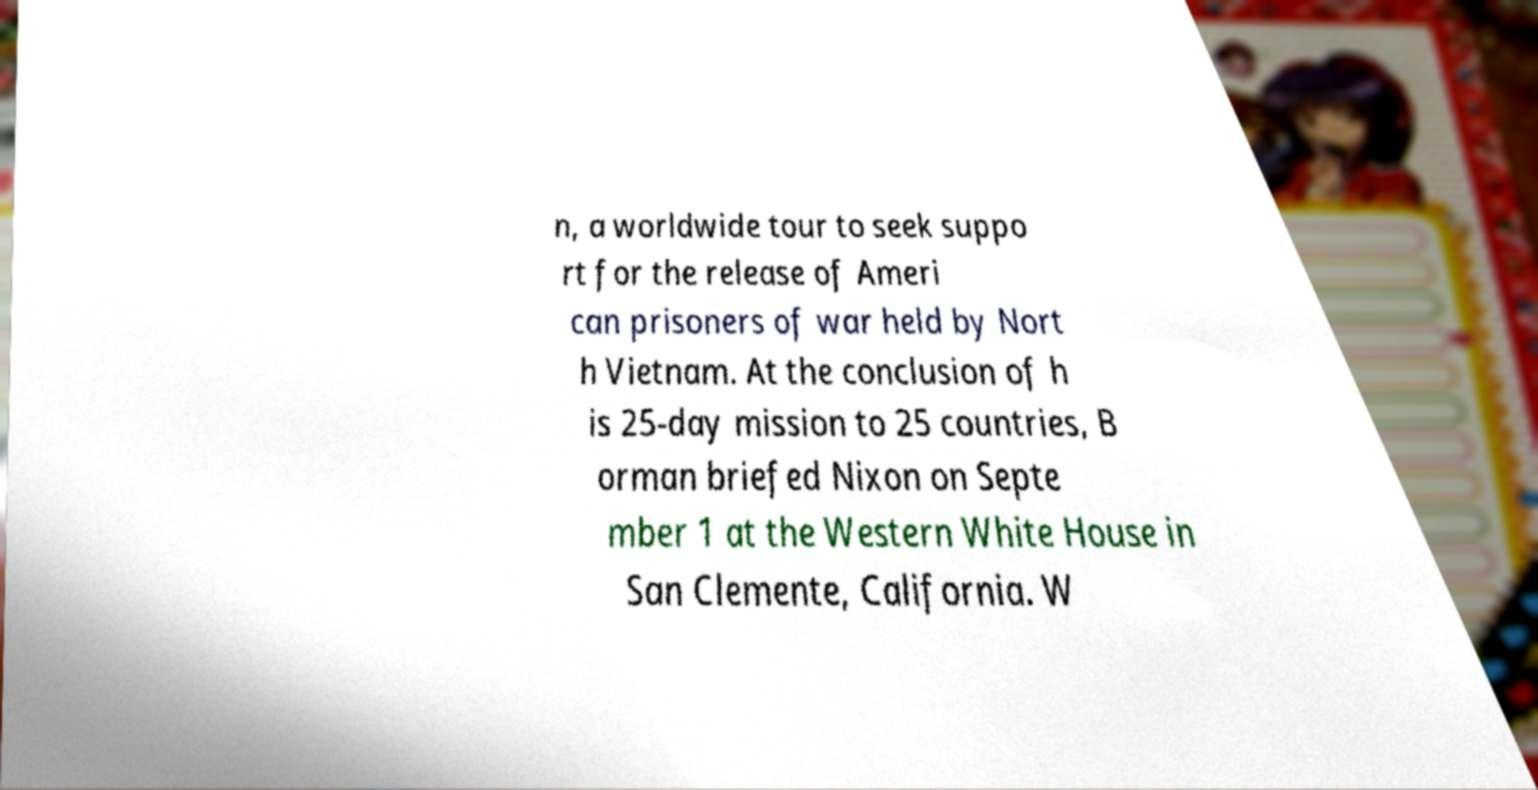I need the written content from this picture converted into text. Can you do that? n, a worldwide tour to seek suppo rt for the release of Ameri can prisoners of war held by Nort h Vietnam. At the conclusion of h is 25-day mission to 25 countries, B orman briefed Nixon on Septe mber 1 at the Western White House in San Clemente, California. W 